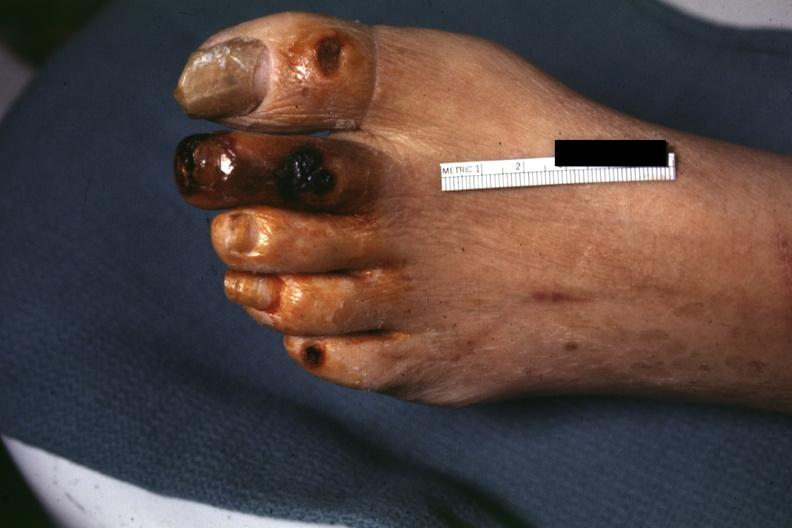what are present?
Answer the question using a single word or phrase. Extremities 